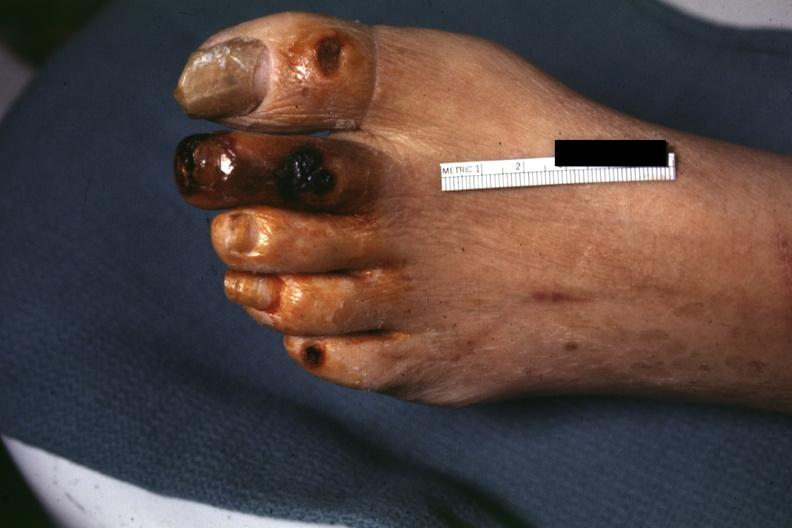what are present?
Answer the question using a single word or phrase. Extremities 